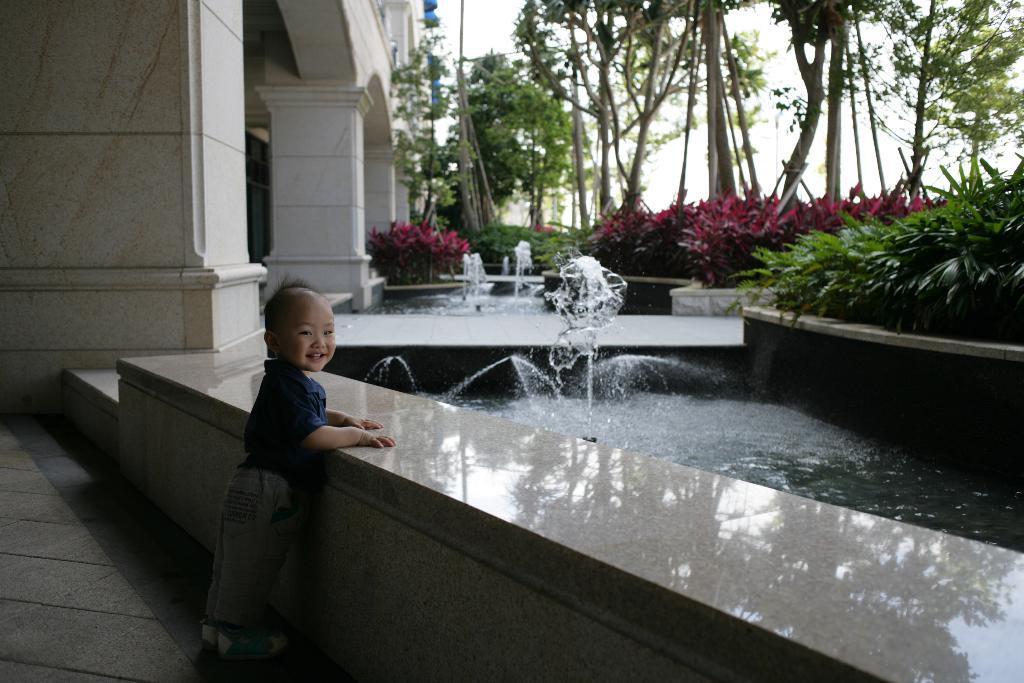Please provide a concise description of this image. In this image we can see a child standing near the wall is smiling. Here we can see the water fountain, plants, pillars, trees and sky in the background. 